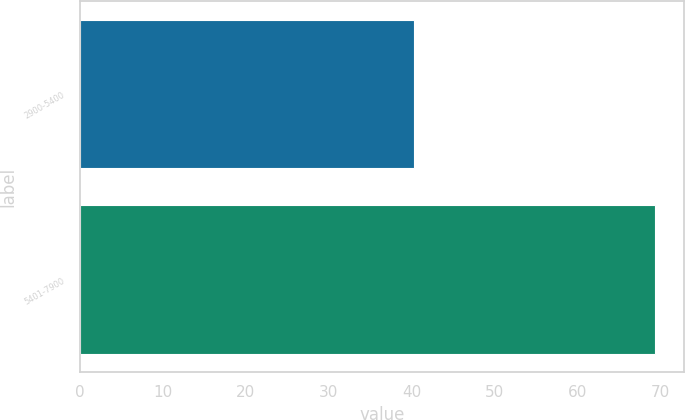Convert chart to OTSL. <chart><loc_0><loc_0><loc_500><loc_500><bar_chart><fcel>2900-5400<fcel>5401-7900<nl><fcel>40.26<fcel>69.4<nl></chart> 